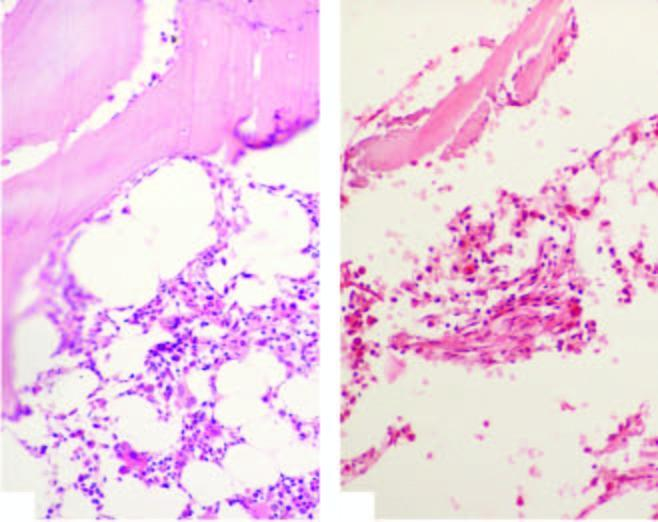what are scanty foci of cellular components composed chiefly of?
Answer the question using a single word or phrase. Lymphoid cells 